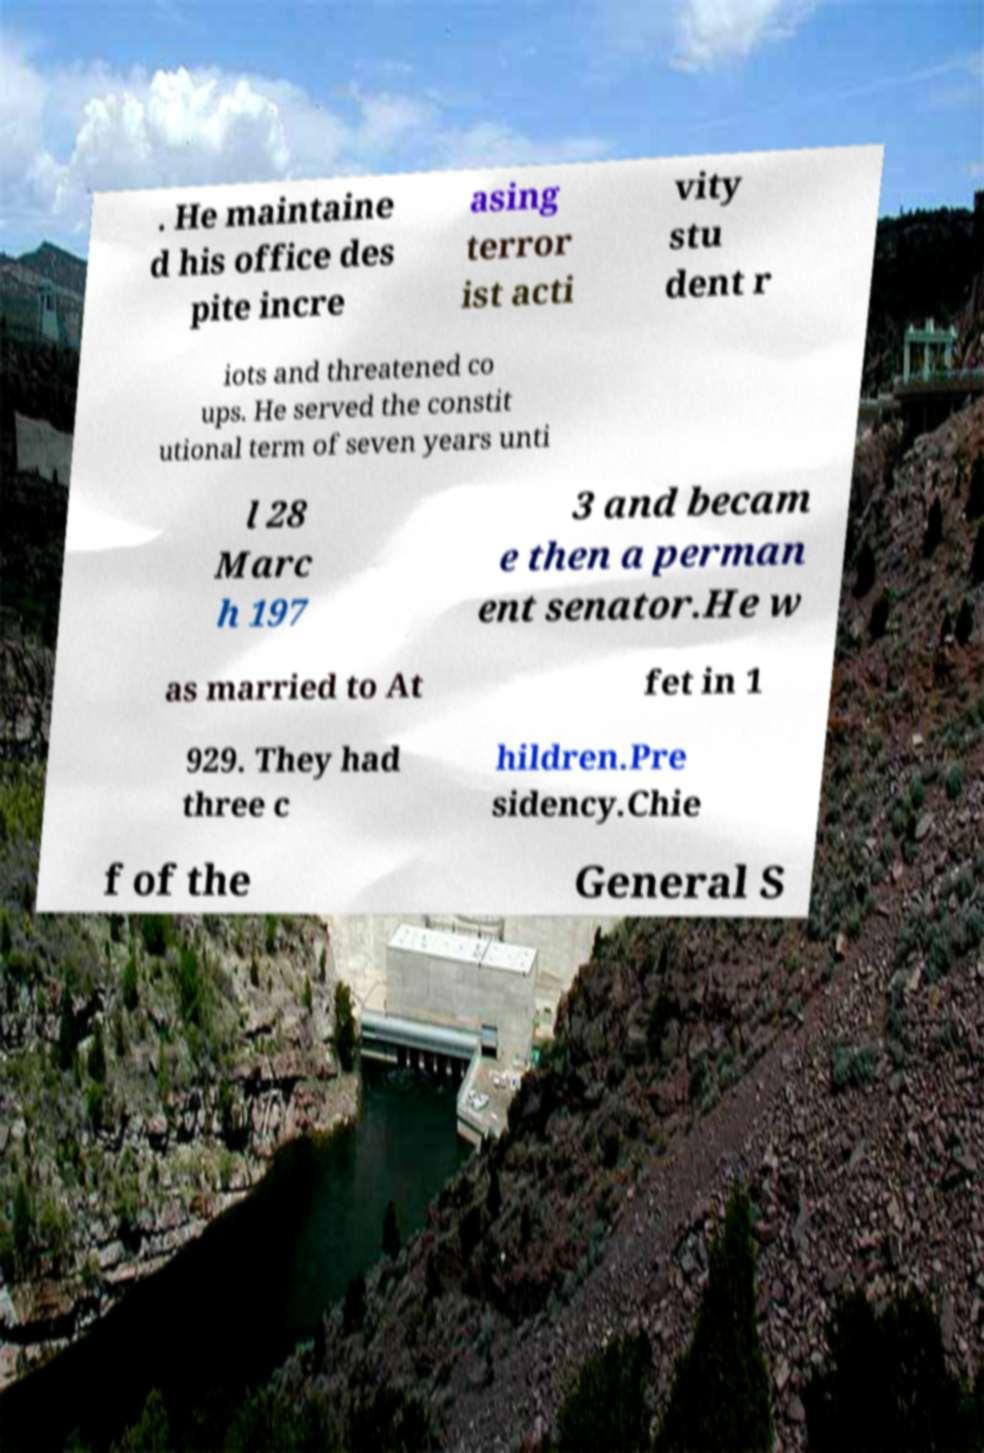There's text embedded in this image that I need extracted. Can you transcribe it verbatim? . He maintaine d his office des pite incre asing terror ist acti vity stu dent r iots and threatened co ups. He served the constit utional term of seven years unti l 28 Marc h 197 3 and becam e then a perman ent senator.He w as married to At fet in 1 929. They had three c hildren.Pre sidency.Chie f of the General S 